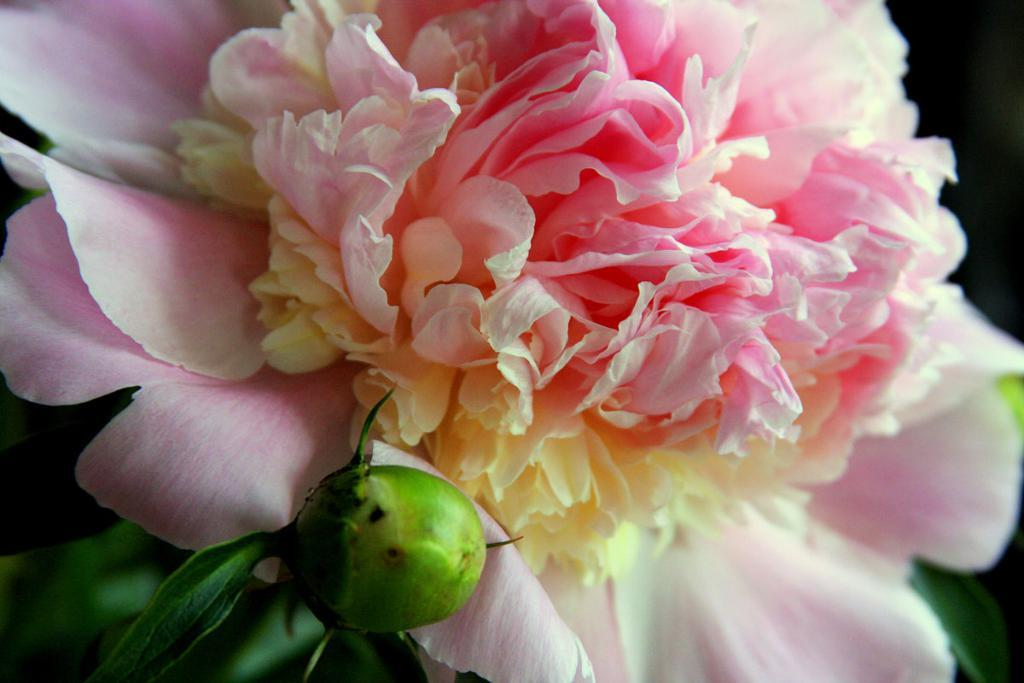What type of plant is featured in the image? There is a flower in the image. What color is the flower? The flower is pink in color. What other part of the plant can be seen in the image? There is a leaf in the image. What color is the leaf? The leaf is green in color. What insect is responsible for the committee's decision in the image? There is no insect or committee present in the image; it features a pink flower and a green leaf. 